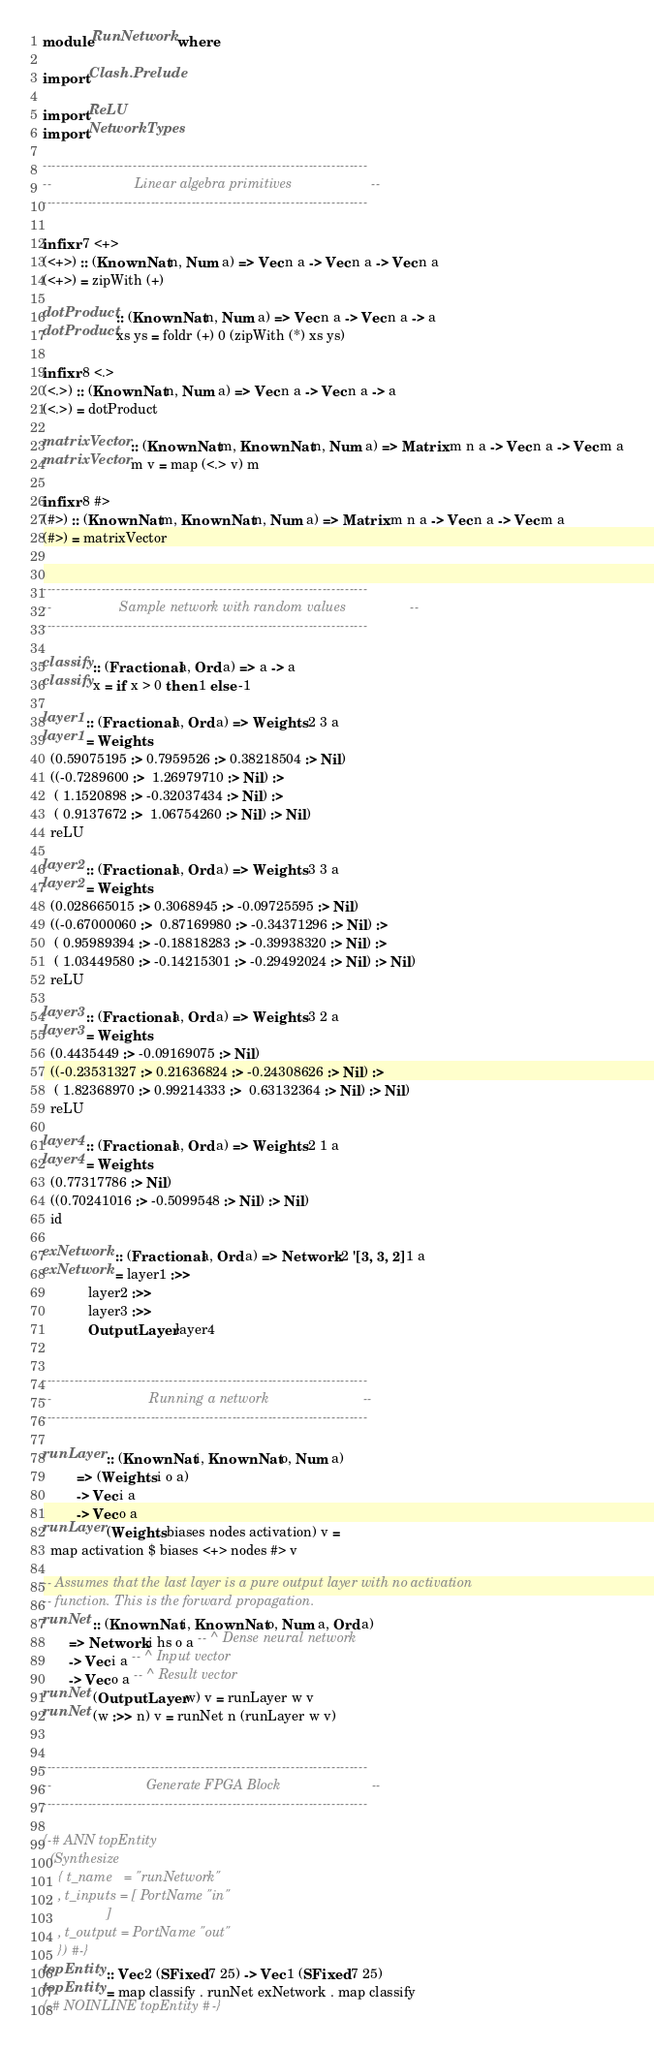Convert code to text. <code><loc_0><loc_0><loc_500><loc_500><_Haskell_>module RunNetwork where

import Clash.Prelude

import ReLU
import NetworkTypes

------------------------------------------------------------------------
--                      Linear algebra primitives                     --
------------------------------------------------------------------------

infixr 7 <+>
(<+>) :: (KnownNat n, Num a) => Vec n a -> Vec n a -> Vec n a
(<+>) = zipWith (+)

dotProduct :: (KnownNat n, Num a) => Vec n a -> Vec n a -> a
dotProduct xs ys = foldr (+) 0 (zipWith (*) xs ys)

infixr 8 <.>
(<.>) :: (KnownNat n, Num a) => Vec n a -> Vec n a -> a
(<.>) = dotProduct

matrixVector :: (KnownNat m, KnownNat n, Num a) => Matrix m n a -> Vec n a -> Vec m a
matrixVector m v = map (<.> v) m

infixr 8 #>
(#>) :: (KnownNat m, KnownNat n, Num a) => Matrix m n a -> Vec n a -> Vec m a
(#>) = matrixVector


------------------------------------------------------------------------
--                  Sample network with random values                 --
------------------------------------------------------------------------

classify :: (Fractional a, Ord a) => a -> a
classify x = if x > 0 then 1 else -1

layer1 :: (Fractional a, Ord a) => Weights 2 3 a
layer1 = Weights
  (0.59075195 :> 0.7959526 :> 0.38218504 :> Nil)
  ((-0.7289600 :>  1.26979710 :> Nil) :>
   ( 1.1520898 :> -0.32037434 :> Nil) :>
   ( 0.9137672 :>  1.06754260 :> Nil) :> Nil)
  reLU

layer2 :: (Fractional a, Ord a) => Weights 3 3 a
layer2 = Weights
  (0.028665015 :> 0.3068945 :> -0.09725595 :> Nil)
  ((-0.67000060 :>  0.87169980 :> -0.34371296 :> Nil) :>
   ( 0.95989394 :> -0.18818283 :> -0.39938320 :> Nil) :>
   ( 1.03449580 :> -0.14215301 :> -0.29492024 :> Nil) :> Nil)
  reLU

layer3 :: (Fractional a, Ord a) => Weights 3 2 a
layer3 = Weights
  (0.4435449 :> -0.09169075 :> Nil)
  ((-0.23531327 :> 0.21636824 :> -0.24308626 :> Nil) :>
   ( 1.82368970 :> 0.99214333 :>  0.63132364 :> Nil) :> Nil)
  reLU

layer4 :: (Fractional a, Ord a) => Weights 2 1 a
layer4 = Weights
  (0.77317786 :> Nil)
  ((0.70241016 :> -0.5099548 :> Nil) :> Nil)
  id

exNetwork :: (Fractional a, Ord a) => Network 2 '[3, 3, 2] 1 a
exNetwork = layer1 :>>
            layer2 :>>
            layer3 :>>
            OutputLayer layer4


------------------------------------------------------------------------
--                          Running a network                         --
------------------------------------------------------------------------

runLayer :: (KnownNat i, KnownNat o, Num a)
         => (Weights i o a)
         -> Vec i a
         -> Vec o a
runLayer (Weights biases nodes activation) v =
  map activation $ biases <+> nodes #> v

-- Assumes that the last layer is a pure output layer with no activation
-- function. This is the forward propagation.
runNet :: (KnownNat i, KnownNat o, Num a, Ord a)
       => Network i hs o a -- ^ Dense neural network
       -> Vec i a -- ^ Input vector
       -> Vec o a -- ^ Result vector
runNet (OutputLayer w) v = runLayer w v
runNet (w :>> n) v = runNet n (runLayer w v)


------------------------------------------------------------------------
--                         Generate FPGA Block                        --
------------------------------------------------------------------------

{-# ANN topEntity
  (Synthesize
    { t_name   = "runNetwork"
    , t_inputs = [ PortName "in"
                 ]
    , t_output = PortName "out"
    }) #-}
topEntity :: Vec 2 (SFixed 7 25) -> Vec 1 (SFixed 7 25)
topEntity = map classify . runNet exNetwork . map classify
{-# NOINLINE topEntity #-}</code> 